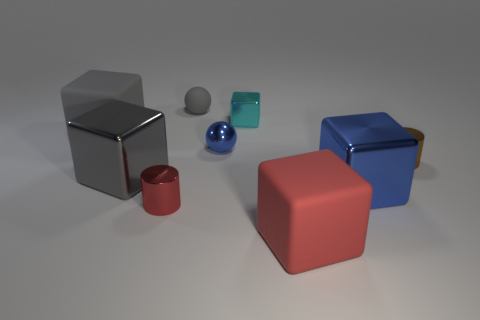Are there any purple things?
Offer a terse response. No. Are there fewer cylinders than purple matte spheres?
Ensure brevity in your answer.  No. Are there any gray rubber things that have the same size as the red cylinder?
Keep it short and to the point. Yes. Does the small gray thing have the same shape as the small object that is in front of the brown metallic cylinder?
Offer a very short reply. No. How many cubes are cyan metallic things or large metal things?
Offer a very short reply. 3. What is the color of the matte ball?
Ensure brevity in your answer.  Gray. Are there more red blocks than gray things?
Offer a very short reply. No. How many objects are either small cylinders that are on the left side of the tiny rubber object or gray rubber cylinders?
Offer a terse response. 1. Does the gray sphere have the same material as the red cube?
Offer a very short reply. Yes. The gray metallic object that is the same shape as the tiny cyan shiny thing is what size?
Your answer should be compact. Large. 